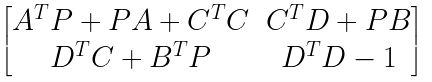<formula> <loc_0><loc_0><loc_500><loc_500>\begin{bmatrix} A ^ { T } P + P A + C ^ { T } C & C ^ { T } D + P B \\ D ^ { T } C + B ^ { T } P & D ^ { T } D - 1 \end{bmatrix}</formula> 